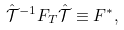Convert formula to latex. <formula><loc_0><loc_0><loc_500><loc_500>\hat { \mathcal { T } } ^ { - 1 } F _ { T } \hat { \mathcal { T } } \equiv F ^ { * } ,</formula> 